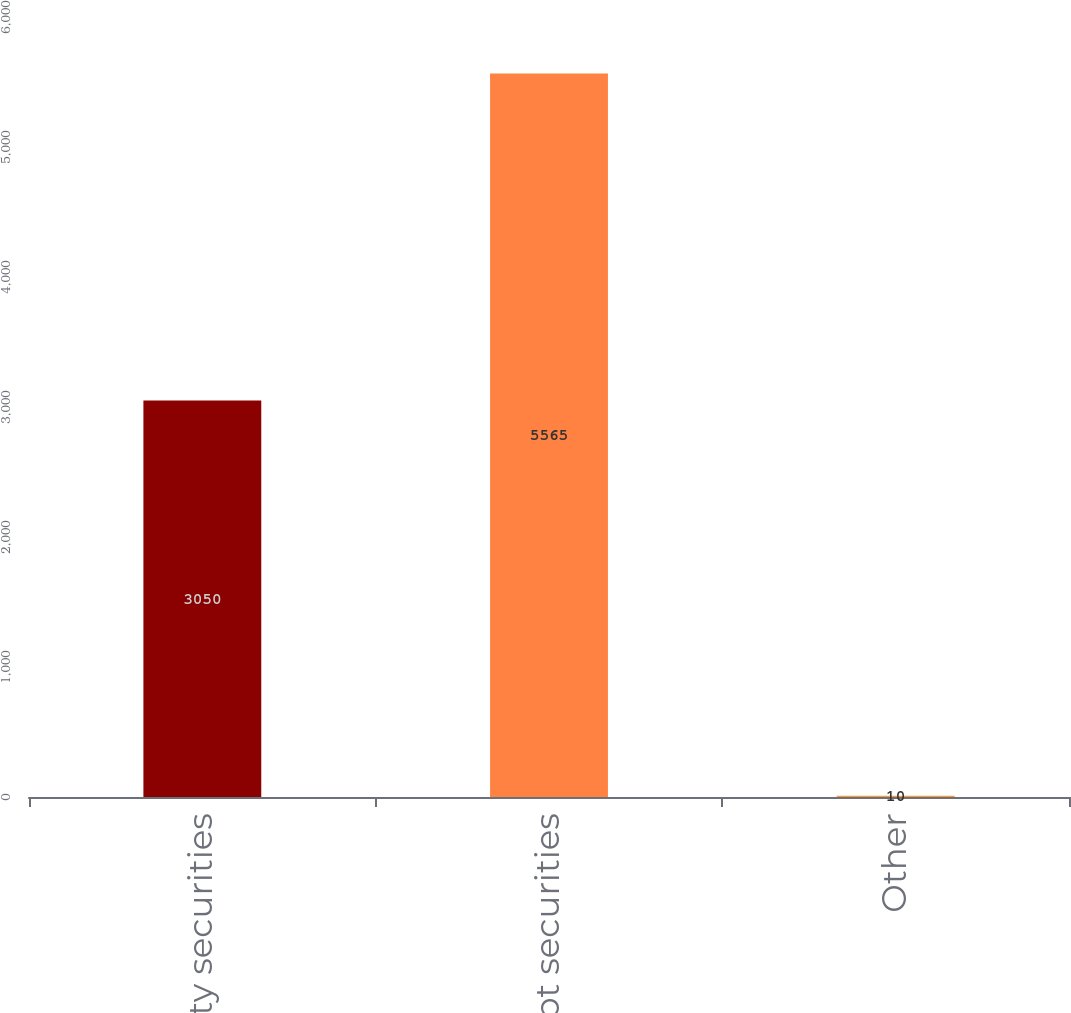<chart> <loc_0><loc_0><loc_500><loc_500><bar_chart><fcel>Equity securities<fcel>Debt securities<fcel>Other<nl><fcel>3050<fcel>5565<fcel>10<nl></chart> 